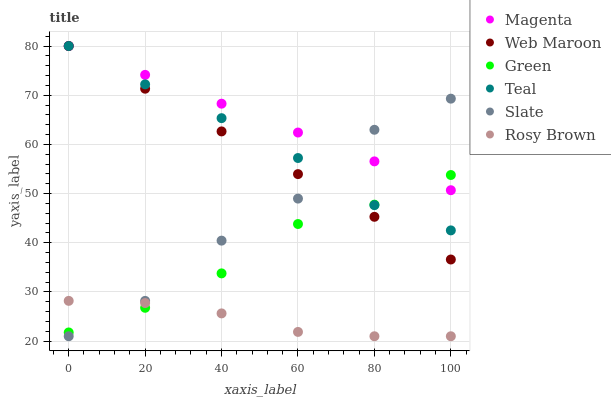Does Rosy Brown have the minimum area under the curve?
Answer yes or no. Yes. Does Magenta have the maximum area under the curve?
Answer yes or no. Yes. Does Web Maroon have the minimum area under the curve?
Answer yes or no. No. Does Web Maroon have the maximum area under the curve?
Answer yes or no. No. Is Web Maroon the smoothest?
Answer yes or no. Yes. Is Slate the roughest?
Answer yes or no. Yes. Is Rosy Brown the smoothest?
Answer yes or no. No. Is Rosy Brown the roughest?
Answer yes or no. No. Does Slate have the lowest value?
Answer yes or no. Yes. Does Web Maroon have the lowest value?
Answer yes or no. No. Does Magenta have the highest value?
Answer yes or no. Yes. Does Rosy Brown have the highest value?
Answer yes or no. No. Is Rosy Brown less than Web Maroon?
Answer yes or no. Yes. Is Teal greater than Rosy Brown?
Answer yes or no. Yes. Does Teal intersect Green?
Answer yes or no. Yes. Is Teal less than Green?
Answer yes or no. No. Is Teal greater than Green?
Answer yes or no. No. Does Rosy Brown intersect Web Maroon?
Answer yes or no. No. 